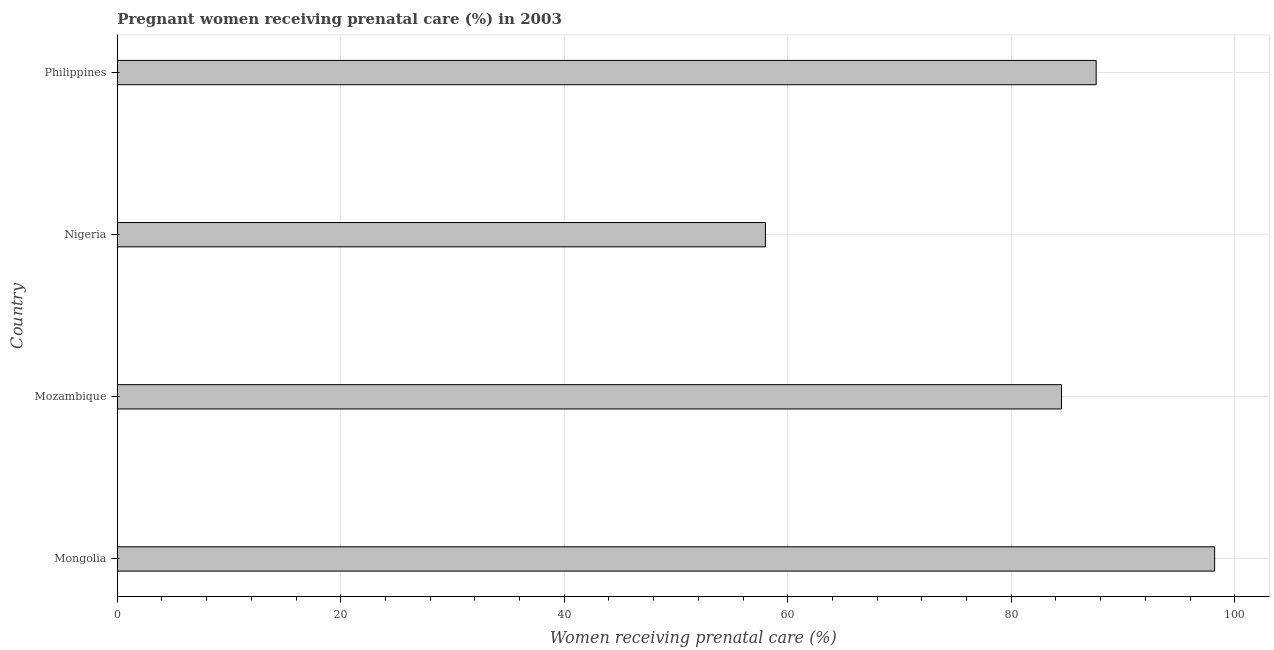What is the title of the graph?
Offer a very short reply. Pregnant women receiving prenatal care (%) in 2003. What is the label or title of the X-axis?
Give a very brief answer. Women receiving prenatal care (%). What is the percentage of pregnant women receiving prenatal care in Mongolia?
Provide a short and direct response. 98.2. Across all countries, what is the maximum percentage of pregnant women receiving prenatal care?
Offer a terse response. 98.2. Across all countries, what is the minimum percentage of pregnant women receiving prenatal care?
Keep it short and to the point. 58. In which country was the percentage of pregnant women receiving prenatal care maximum?
Offer a terse response. Mongolia. In which country was the percentage of pregnant women receiving prenatal care minimum?
Offer a very short reply. Nigeria. What is the sum of the percentage of pregnant women receiving prenatal care?
Offer a very short reply. 328.3. What is the difference between the percentage of pregnant women receiving prenatal care in Nigeria and Philippines?
Your answer should be compact. -29.6. What is the average percentage of pregnant women receiving prenatal care per country?
Offer a very short reply. 82.08. What is the median percentage of pregnant women receiving prenatal care?
Offer a terse response. 86.05. In how many countries, is the percentage of pregnant women receiving prenatal care greater than 40 %?
Your answer should be compact. 4. What is the ratio of the percentage of pregnant women receiving prenatal care in Nigeria to that in Philippines?
Give a very brief answer. 0.66. What is the difference between the highest and the lowest percentage of pregnant women receiving prenatal care?
Offer a very short reply. 40.2. How many countries are there in the graph?
Your answer should be compact. 4. What is the difference between two consecutive major ticks on the X-axis?
Your answer should be compact. 20. What is the Women receiving prenatal care (%) in Mongolia?
Provide a succinct answer. 98.2. What is the Women receiving prenatal care (%) of Mozambique?
Make the answer very short. 84.5. What is the Women receiving prenatal care (%) of Philippines?
Provide a succinct answer. 87.6. What is the difference between the Women receiving prenatal care (%) in Mongolia and Mozambique?
Your response must be concise. 13.7. What is the difference between the Women receiving prenatal care (%) in Mongolia and Nigeria?
Give a very brief answer. 40.2. What is the difference between the Women receiving prenatal care (%) in Mongolia and Philippines?
Keep it short and to the point. 10.6. What is the difference between the Women receiving prenatal care (%) in Mozambique and Nigeria?
Keep it short and to the point. 26.5. What is the difference between the Women receiving prenatal care (%) in Nigeria and Philippines?
Give a very brief answer. -29.6. What is the ratio of the Women receiving prenatal care (%) in Mongolia to that in Mozambique?
Provide a short and direct response. 1.16. What is the ratio of the Women receiving prenatal care (%) in Mongolia to that in Nigeria?
Provide a short and direct response. 1.69. What is the ratio of the Women receiving prenatal care (%) in Mongolia to that in Philippines?
Provide a succinct answer. 1.12. What is the ratio of the Women receiving prenatal care (%) in Mozambique to that in Nigeria?
Offer a very short reply. 1.46. What is the ratio of the Women receiving prenatal care (%) in Nigeria to that in Philippines?
Make the answer very short. 0.66. 